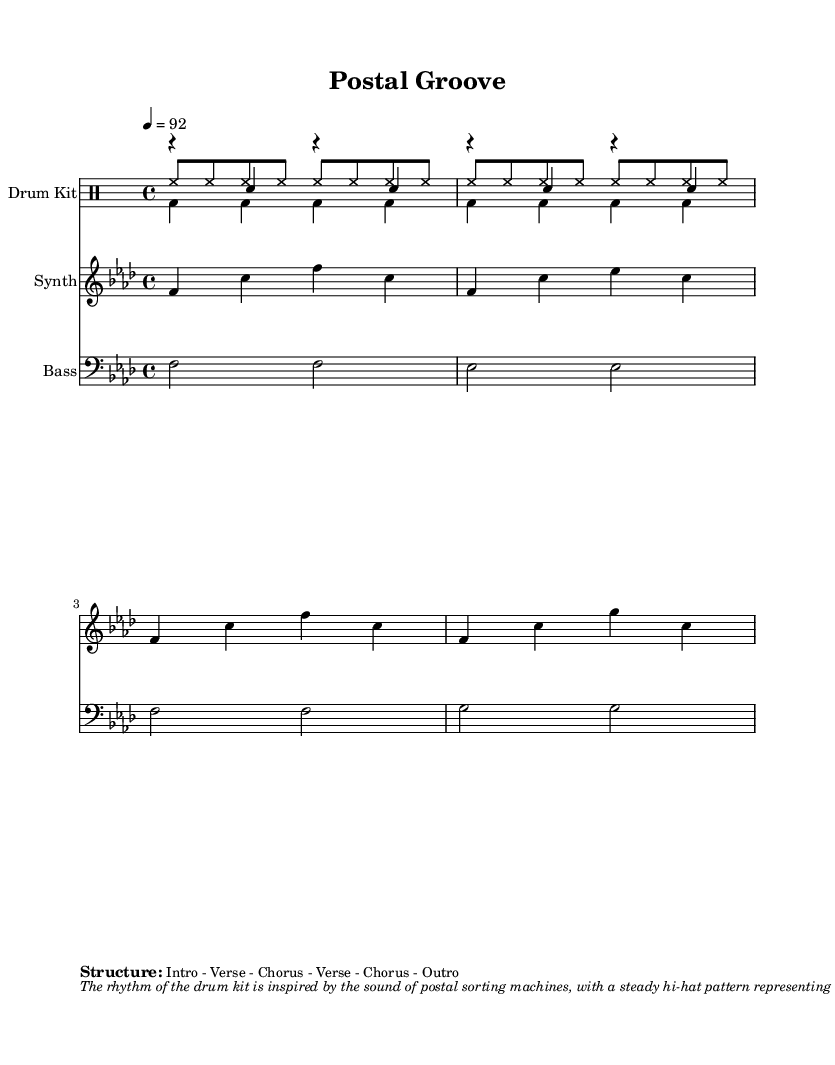What is the key signature of this music? The key signature is indicated by the number of flats present on the staff. Here, there are four flats (B, E, A, D), which identifies it as F minor.
Answer: F minor What is the time signature of this music? The time signature is represented by the upper and lower numbers at the beginning of the staff. Here, the upper number is 4, and the lower number is 4, indicating a 4/4 time signature.
Answer: 4/4 What is the tempo marking for the piece? The tempo is indicated by a number on the score indicating beats per minute. In this case, it states "4 = 92," meaning there are 92 beats in one minute of the music.
Answer: 92 What type of percussion instruments are used in this piece? The instruments are identified as being part of a specific ensemble for percussion. The score distinctly mentions a "Drum Kit," which consists of hi-hats, kick drums, and snares.
Answer: Drum Kit How many measures are included in the synth part? To count the measures, we observe the number of bar lines in the synth staff. The synth part has four measures total, each separated by a bar line.
Answer: 4 What is the primary theme represented in the synth melody? The synth melody is inspired by an external sound, specifically described in the markup. It mimics "the beeping sounds of barcode scanners," reflecting a postal theme in its arrangement.
Answer: Beeping sounds of barcode scanners What structural form does the arrangement follow? The structure is explicitly outlined in the score as "Intro - Verse - Chorus - Verse - Chorus - Outro," indicating the specific order of sections in the music.
Answer: Intro - Verse - Chorus - Verse - Chorus - Outro 